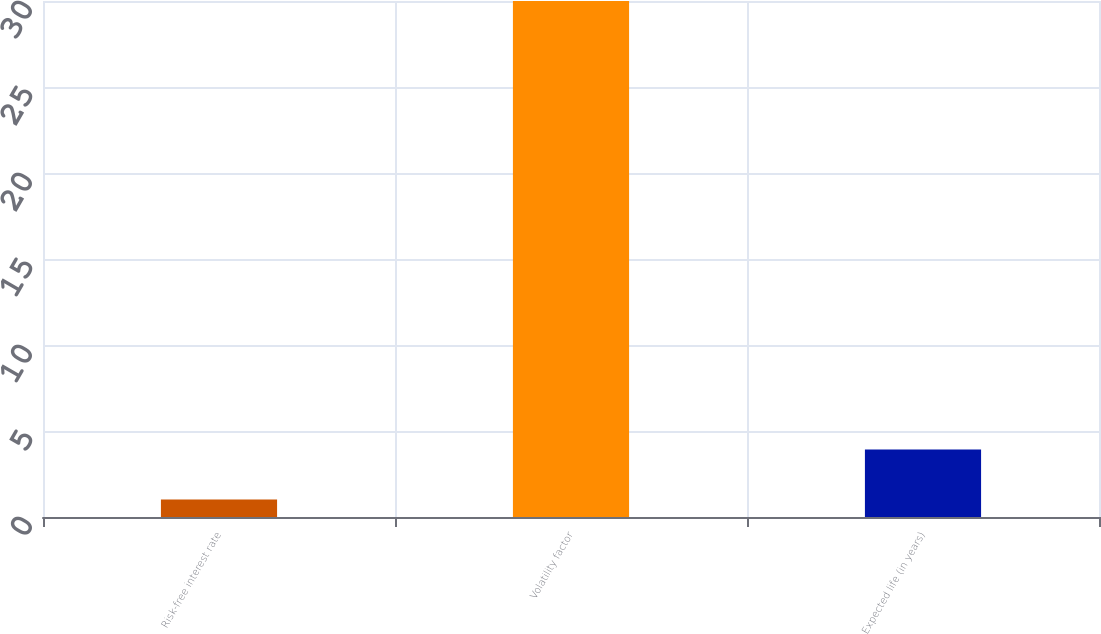Convert chart to OTSL. <chart><loc_0><loc_0><loc_500><loc_500><bar_chart><fcel>Risk-free interest rate<fcel>Volatility factor<fcel>Expected life (in years)<nl><fcel>1.02<fcel>30<fcel>3.92<nl></chart> 